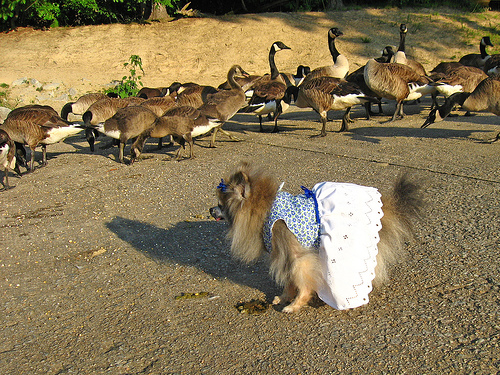<image>
Is the duck next to the dog? Yes. The duck is positioned adjacent to the dog, located nearby in the same general area. 